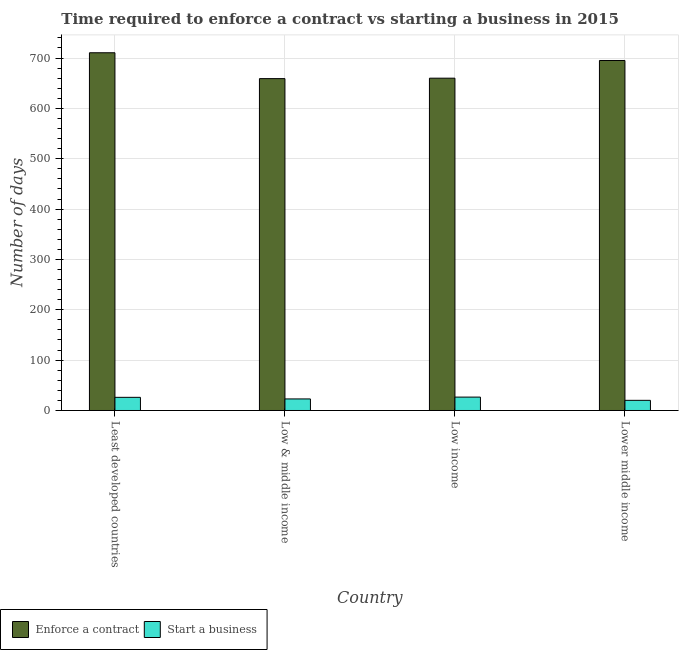How many groups of bars are there?
Offer a very short reply. 4. Are the number of bars per tick equal to the number of legend labels?
Offer a very short reply. Yes. How many bars are there on the 1st tick from the left?
Your answer should be very brief. 2. What is the label of the 4th group of bars from the left?
Your answer should be very brief. Lower middle income. In how many cases, is the number of bars for a given country not equal to the number of legend labels?
Offer a terse response. 0. What is the number of days to enforece a contract in Low & middle income?
Offer a terse response. 659.09. Across all countries, what is the maximum number of days to enforece a contract?
Your answer should be compact. 710.46. Across all countries, what is the minimum number of days to start a business?
Provide a short and direct response. 20.16. In which country was the number of days to enforece a contract maximum?
Offer a very short reply. Least developed countries. What is the total number of days to enforece a contract in the graph?
Your answer should be compact. 2724.63. What is the difference between the number of days to enforece a contract in Least developed countries and that in Lower middle income?
Provide a short and direct response. 15.34. What is the difference between the number of days to enforece a contract in Lower middle income and the number of days to start a business in Low & middle income?
Provide a short and direct response. 672.18. What is the average number of days to enforece a contract per country?
Ensure brevity in your answer.  681.16. What is the difference between the number of days to start a business and number of days to enforece a contract in Least developed countries?
Offer a very short reply. -684.34. In how many countries, is the number of days to start a business greater than 100 days?
Give a very brief answer. 0. What is the ratio of the number of days to enforece a contract in Least developed countries to that in Low & middle income?
Provide a short and direct response. 1.08. What is the difference between the highest and the second highest number of days to start a business?
Ensure brevity in your answer.  0.45. What is the difference between the highest and the lowest number of days to enforece a contract?
Make the answer very short. 51.37. What does the 1st bar from the left in Low & middle income represents?
Provide a short and direct response. Enforce a contract. What does the 1st bar from the right in Least developed countries represents?
Make the answer very short. Start a business. How many bars are there?
Offer a terse response. 8. Are all the bars in the graph horizontal?
Your answer should be very brief. No. How many countries are there in the graph?
Your answer should be very brief. 4. What is the difference between two consecutive major ticks on the Y-axis?
Your answer should be compact. 100. Are the values on the major ticks of Y-axis written in scientific E-notation?
Provide a short and direct response. No. What is the title of the graph?
Your answer should be compact. Time required to enforce a contract vs starting a business in 2015. Does "Broad money growth" appear as one of the legend labels in the graph?
Provide a succinct answer. No. What is the label or title of the Y-axis?
Your answer should be compact. Number of days. What is the Number of days in Enforce a contract in Least developed countries?
Your response must be concise. 710.46. What is the Number of days of Start a business in Least developed countries?
Your answer should be very brief. 26.12. What is the Number of days in Enforce a contract in Low & middle income?
Provide a succinct answer. 659.09. What is the Number of days in Start a business in Low & middle income?
Provide a short and direct response. 22.94. What is the Number of days in Enforce a contract in Low income?
Offer a terse response. 659.97. What is the Number of days in Start a business in Low income?
Offer a very short reply. 26.57. What is the Number of days in Enforce a contract in Lower middle income?
Keep it short and to the point. 695.12. What is the Number of days of Start a business in Lower middle income?
Provide a short and direct response. 20.16. Across all countries, what is the maximum Number of days of Enforce a contract?
Provide a short and direct response. 710.46. Across all countries, what is the maximum Number of days of Start a business?
Provide a succinct answer. 26.57. Across all countries, what is the minimum Number of days of Enforce a contract?
Offer a very short reply. 659.09. Across all countries, what is the minimum Number of days of Start a business?
Provide a succinct answer. 20.16. What is the total Number of days in Enforce a contract in the graph?
Ensure brevity in your answer.  2724.63. What is the total Number of days of Start a business in the graph?
Your answer should be very brief. 95.78. What is the difference between the Number of days in Enforce a contract in Least developed countries and that in Low & middle income?
Provide a succinct answer. 51.37. What is the difference between the Number of days in Start a business in Least developed countries and that in Low & middle income?
Give a very brief answer. 3.18. What is the difference between the Number of days of Enforce a contract in Least developed countries and that in Low income?
Ensure brevity in your answer.  50.49. What is the difference between the Number of days in Start a business in Least developed countries and that in Low income?
Make the answer very short. -0.45. What is the difference between the Number of days in Enforce a contract in Least developed countries and that in Lower middle income?
Keep it short and to the point. 15.34. What is the difference between the Number of days in Start a business in Least developed countries and that in Lower middle income?
Your answer should be compact. 5.96. What is the difference between the Number of days in Enforce a contract in Low & middle income and that in Low income?
Your response must be concise. -0.87. What is the difference between the Number of days in Start a business in Low & middle income and that in Low income?
Offer a terse response. -3.63. What is the difference between the Number of days of Enforce a contract in Low & middle income and that in Lower middle income?
Keep it short and to the point. -36.03. What is the difference between the Number of days of Start a business in Low & middle income and that in Lower middle income?
Provide a succinct answer. 2.78. What is the difference between the Number of days of Enforce a contract in Low income and that in Lower middle income?
Keep it short and to the point. -35.15. What is the difference between the Number of days of Start a business in Low income and that in Lower middle income?
Your answer should be compact. 6.41. What is the difference between the Number of days in Enforce a contract in Least developed countries and the Number of days in Start a business in Low & middle income?
Your answer should be very brief. 687.52. What is the difference between the Number of days of Enforce a contract in Least developed countries and the Number of days of Start a business in Low income?
Your response must be concise. 683.89. What is the difference between the Number of days in Enforce a contract in Least developed countries and the Number of days in Start a business in Lower middle income?
Ensure brevity in your answer.  690.3. What is the difference between the Number of days of Enforce a contract in Low & middle income and the Number of days of Start a business in Low income?
Provide a short and direct response. 632.52. What is the difference between the Number of days in Enforce a contract in Low & middle income and the Number of days in Start a business in Lower middle income?
Keep it short and to the point. 638.93. What is the difference between the Number of days in Enforce a contract in Low income and the Number of days in Start a business in Lower middle income?
Provide a succinct answer. 639.81. What is the average Number of days of Enforce a contract per country?
Your answer should be very brief. 681.16. What is the average Number of days in Start a business per country?
Make the answer very short. 23.95. What is the difference between the Number of days of Enforce a contract and Number of days of Start a business in Least developed countries?
Provide a short and direct response. 684.34. What is the difference between the Number of days of Enforce a contract and Number of days of Start a business in Low & middle income?
Your answer should be very brief. 636.15. What is the difference between the Number of days in Enforce a contract and Number of days in Start a business in Low income?
Keep it short and to the point. 633.4. What is the difference between the Number of days of Enforce a contract and Number of days of Start a business in Lower middle income?
Provide a succinct answer. 674.96. What is the ratio of the Number of days of Enforce a contract in Least developed countries to that in Low & middle income?
Offer a terse response. 1.08. What is the ratio of the Number of days in Start a business in Least developed countries to that in Low & middle income?
Provide a short and direct response. 1.14. What is the ratio of the Number of days in Enforce a contract in Least developed countries to that in Low income?
Your answer should be compact. 1.08. What is the ratio of the Number of days in Start a business in Least developed countries to that in Low income?
Give a very brief answer. 0.98. What is the ratio of the Number of days in Enforce a contract in Least developed countries to that in Lower middle income?
Your answer should be compact. 1.02. What is the ratio of the Number of days of Start a business in Least developed countries to that in Lower middle income?
Make the answer very short. 1.3. What is the ratio of the Number of days in Enforce a contract in Low & middle income to that in Low income?
Provide a succinct answer. 1. What is the ratio of the Number of days of Start a business in Low & middle income to that in Low income?
Offer a terse response. 0.86. What is the ratio of the Number of days of Enforce a contract in Low & middle income to that in Lower middle income?
Provide a succinct answer. 0.95. What is the ratio of the Number of days of Start a business in Low & middle income to that in Lower middle income?
Provide a succinct answer. 1.14. What is the ratio of the Number of days in Enforce a contract in Low income to that in Lower middle income?
Your answer should be very brief. 0.95. What is the ratio of the Number of days of Start a business in Low income to that in Lower middle income?
Provide a succinct answer. 1.32. What is the difference between the highest and the second highest Number of days in Enforce a contract?
Provide a short and direct response. 15.34. What is the difference between the highest and the second highest Number of days of Start a business?
Offer a very short reply. 0.45. What is the difference between the highest and the lowest Number of days of Enforce a contract?
Ensure brevity in your answer.  51.37. What is the difference between the highest and the lowest Number of days in Start a business?
Provide a short and direct response. 6.41. 